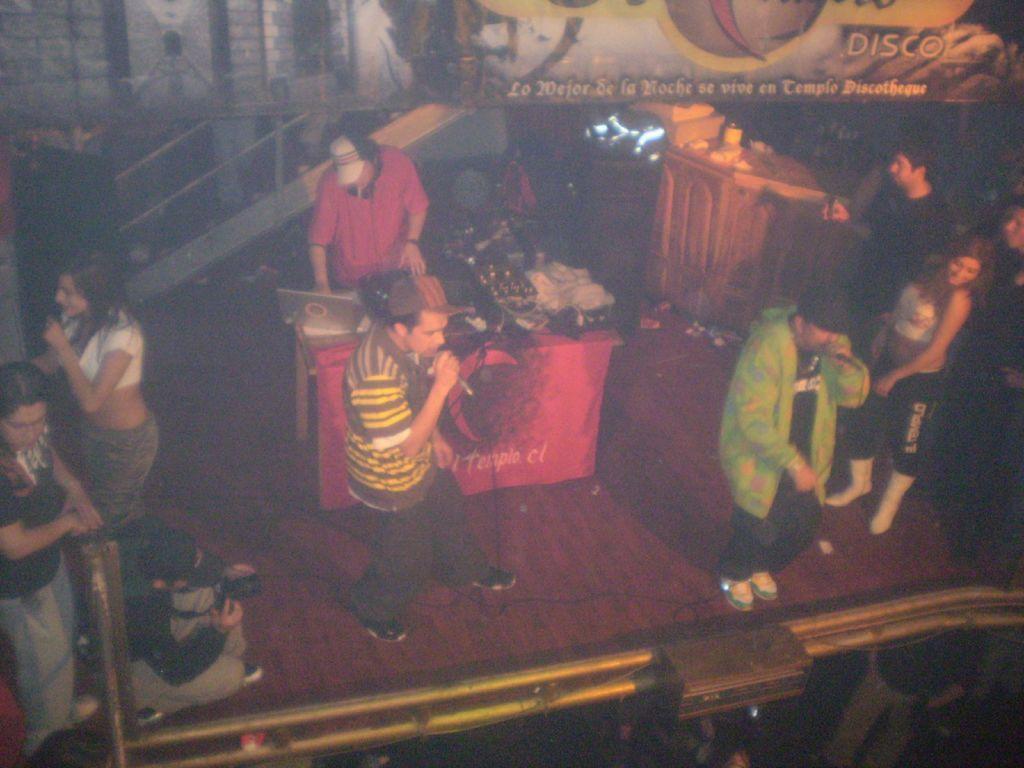Describe this image in one or two sentences. In the picture I can see these three people are holding mics in their hands and singing and this person wearing red T-shirt is standing there and there are laptop and few more objects placed on the table. In the background, we can see the stairs, banner and few more people standing. Here we can see a person holding camera and sitting on the stage. 